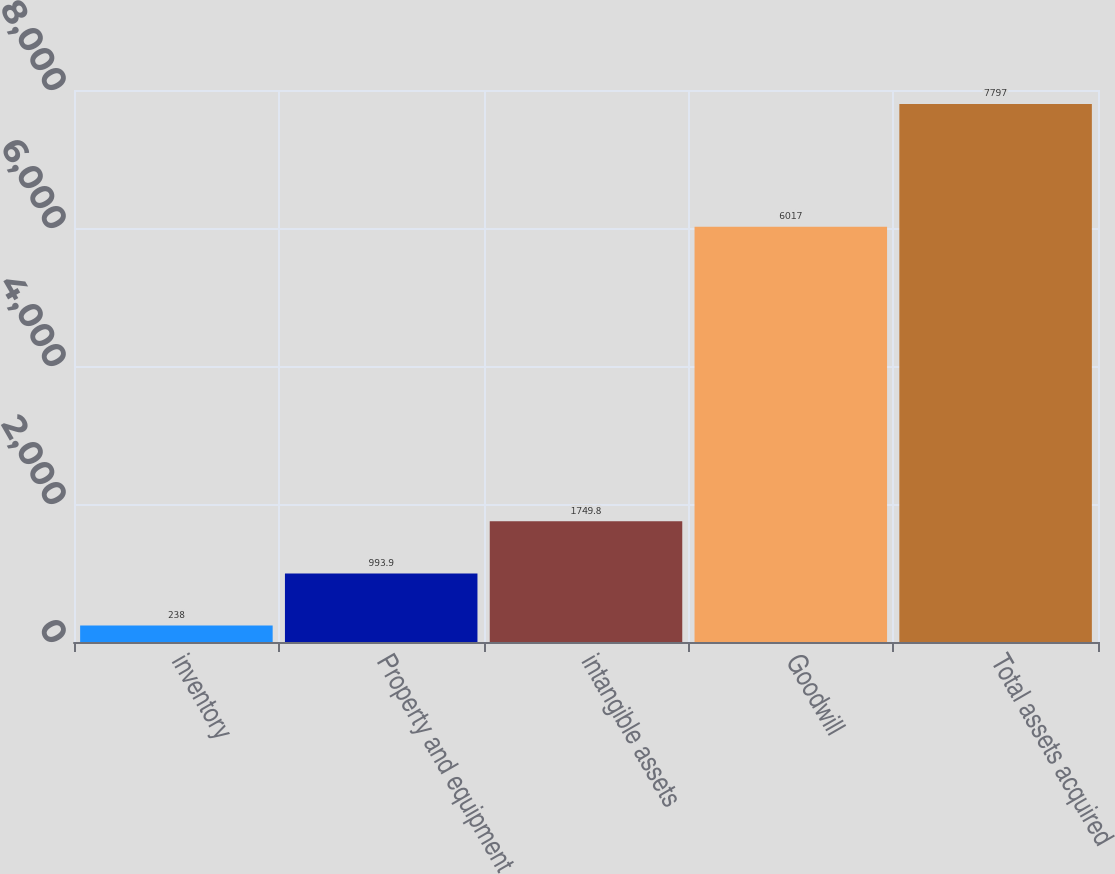Convert chart. <chart><loc_0><loc_0><loc_500><loc_500><bar_chart><fcel>inventory<fcel>Property and equipment<fcel>intangible assets<fcel>Goodwill<fcel>Total assets acquired<nl><fcel>238<fcel>993.9<fcel>1749.8<fcel>6017<fcel>7797<nl></chart> 